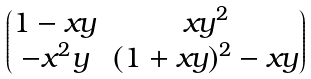<formula> <loc_0><loc_0><loc_500><loc_500>\begin{pmatrix} 1 - x y & x y ^ { 2 } \\ - x ^ { 2 } y & ( 1 + x y ) ^ { 2 } - x y \end{pmatrix}</formula> 